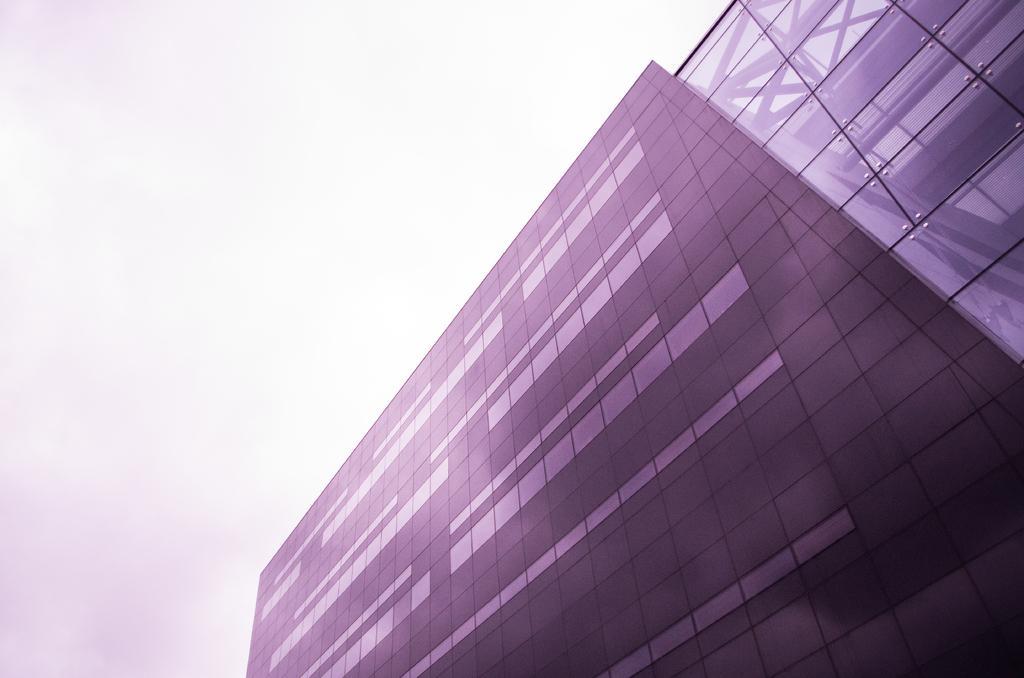Please provide a concise description of this image. In this image I can see the glass building and the sky is in white color. 